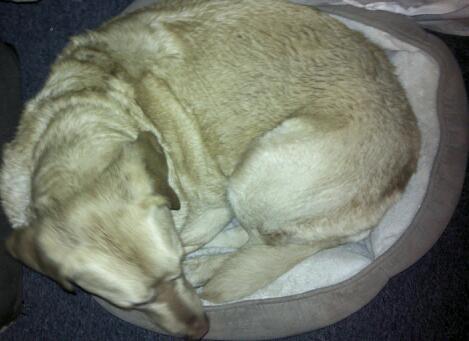What breed of dog is this?
Answer briefly. Chihuahua. How many animals are in the picture?
Keep it brief. 1. What is the dog sleeping on?
Write a very short answer. Dog bed. 